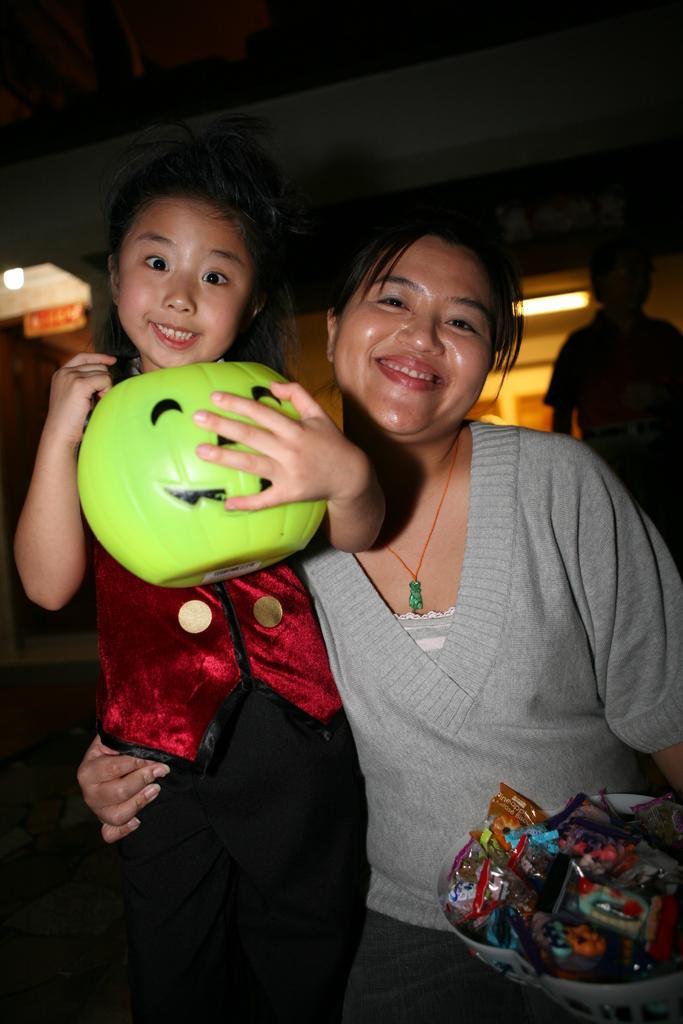Could you give a brief overview of what you see in this image? In this picture there is a woman who is wearing grey t-shirt and trouser, beside him there is a girl who is holding green color object. In the bottom right corner i can see many chocolates which are kept in this basket. In the back there is a boy who is standing near to the door. At the top of the building there is a roof. 